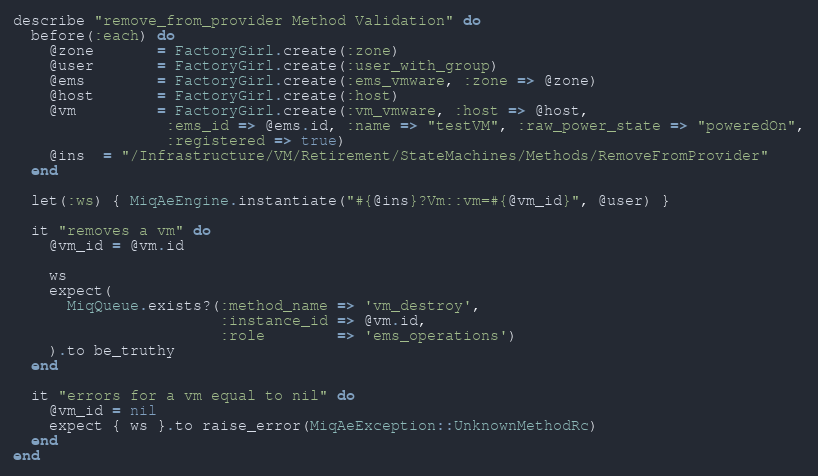<code> <loc_0><loc_0><loc_500><loc_500><_Ruby_>describe "remove_from_provider Method Validation" do
  before(:each) do
    @zone       = FactoryGirl.create(:zone)
    @user       = FactoryGirl.create(:user_with_group)
    @ems        = FactoryGirl.create(:ems_vmware, :zone => @zone)
    @host       = FactoryGirl.create(:host)
    @vm         = FactoryGirl.create(:vm_vmware, :host => @host,
                 :ems_id => @ems.id, :name => "testVM", :raw_power_state => "poweredOn",
                 :registered => true)
    @ins  = "/Infrastructure/VM/Retirement/StateMachines/Methods/RemoveFromProvider"
  end

  let(:ws) { MiqAeEngine.instantiate("#{@ins}?Vm::vm=#{@vm_id}", @user) }

  it "removes a vm" do
    @vm_id = @vm.id

    ws
    expect(
      MiqQueue.exists?(:method_name => 'vm_destroy',
                       :instance_id => @vm.id,
                       :role        => 'ems_operations')
    ).to be_truthy
  end

  it "errors for a vm equal to nil" do
    @vm_id = nil
    expect { ws }.to raise_error(MiqAeException::UnknownMethodRc)
  end
end
</code> 